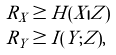Convert formula to latex. <formula><loc_0><loc_0><loc_500><loc_500>& R _ { X } \geq H ( X | Z ) \\ & R _ { Y } \geq I ( Y ; Z ) ,</formula> 